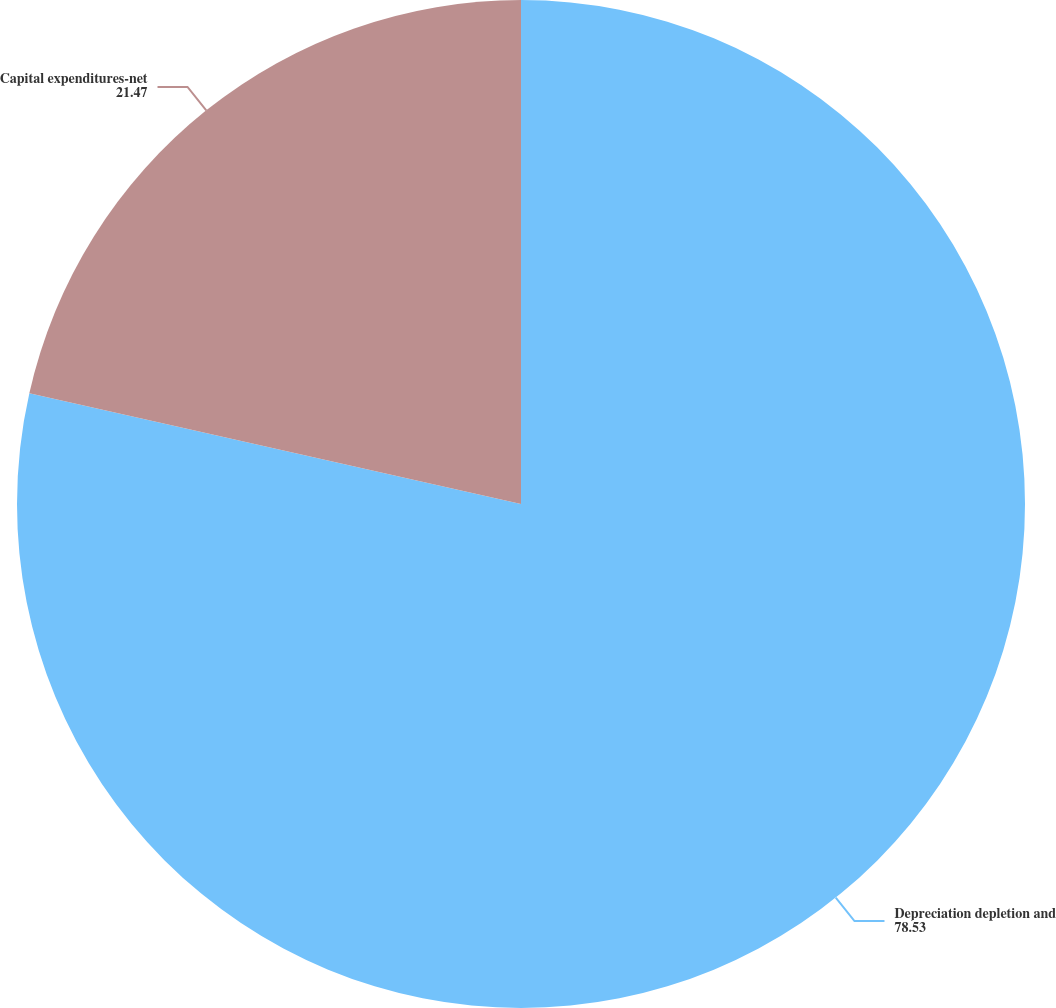Convert chart. <chart><loc_0><loc_0><loc_500><loc_500><pie_chart><fcel>Depreciation depletion and<fcel>Capital expenditures-net<nl><fcel>78.53%<fcel>21.47%<nl></chart> 